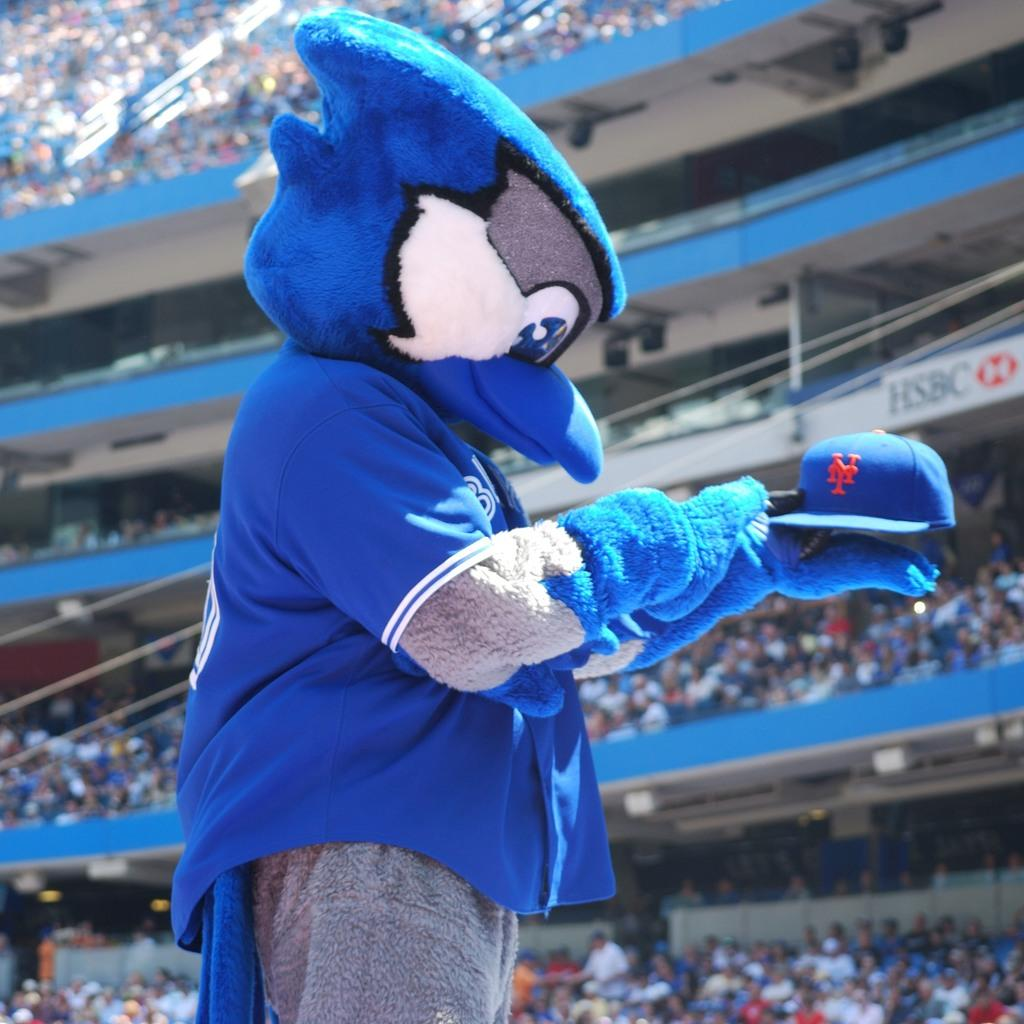What is the main subject of the image? There is a mascot in the image. What is the mascot holding? The mascot is holding a cap. What can be seen in the background of the image? There is a group of people, a poster, and other objects visible in the background of the image. How many fish are swimming in the cap held by the mascot? There are no fish visible in the image, as the mascot is holding a cap, not a body of water. 